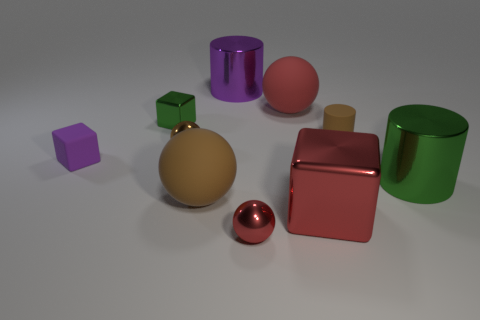How many large red rubber things have the same shape as the brown shiny object?
Keep it short and to the point. 1. Are there any yellow matte objects?
Your answer should be compact. No. Is the tiny green cube made of the same material as the purple object that is in front of the brown rubber cylinder?
Provide a short and direct response. No. What is the material of the brown ball that is the same size as the purple cylinder?
Make the answer very short. Rubber. Are there any brown spheres that have the same material as the big green cylinder?
Keep it short and to the point. Yes. Are there any red metal things on the right side of the small rubber object on the left side of the large thing in front of the large brown object?
Keep it short and to the point. Yes. What shape is the brown metallic object that is the same size as the purple rubber block?
Your answer should be compact. Sphere. There is a red ball that is behind the brown matte ball; is it the same size as the brown rubber object in front of the green metal cylinder?
Give a very brief answer. Yes. How many purple metallic cylinders are there?
Ensure brevity in your answer.  1. There is a matte sphere that is in front of the big metallic object on the right side of the shiny cube right of the large purple metallic object; what is its size?
Offer a very short reply. Large. 